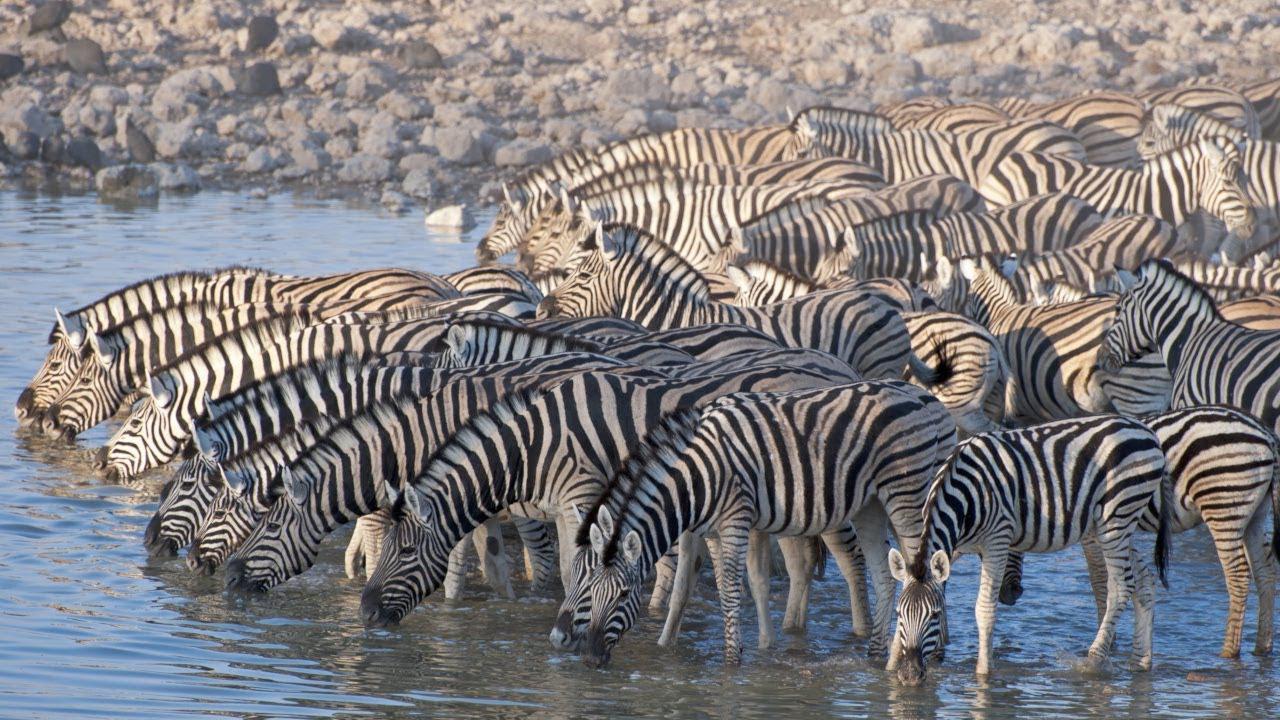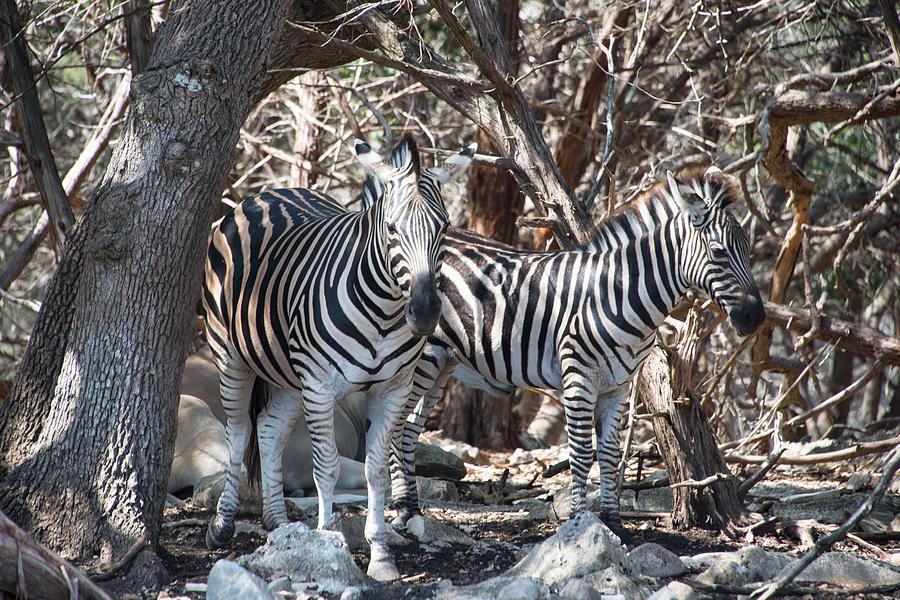The first image is the image on the left, the second image is the image on the right. For the images shown, is this caption "There are at least two zebras  facing right forward." true? Answer yes or no. Yes. 